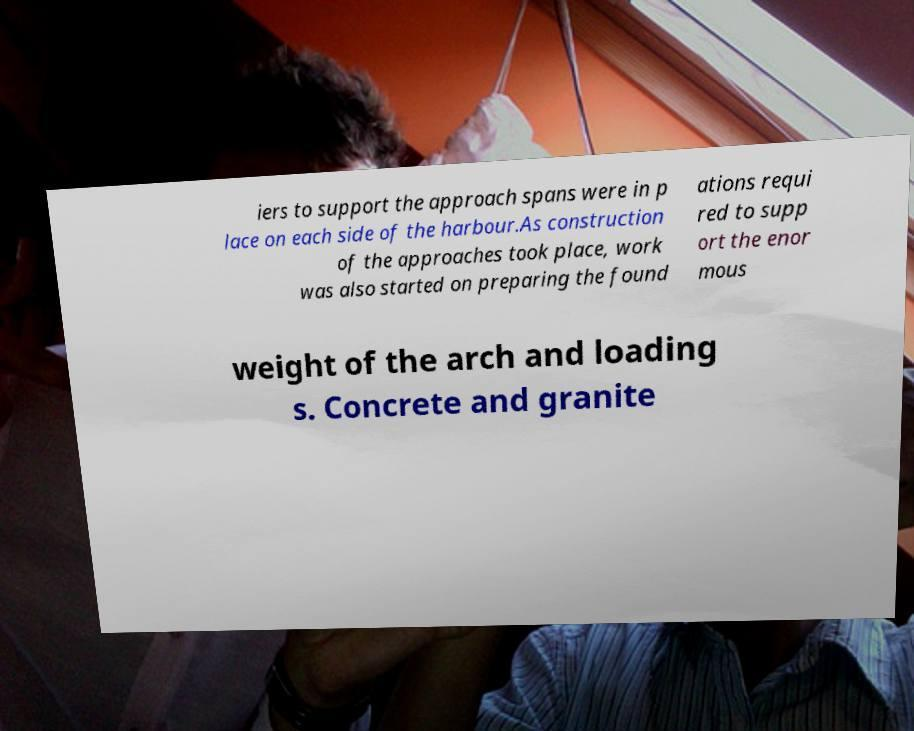Can you accurately transcribe the text from the provided image for me? iers to support the approach spans were in p lace on each side of the harbour.As construction of the approaches took place, work was also started on preparing the found ations requi red to supp ort the enor mous weight of the arch and loading s. Concrete and granite 